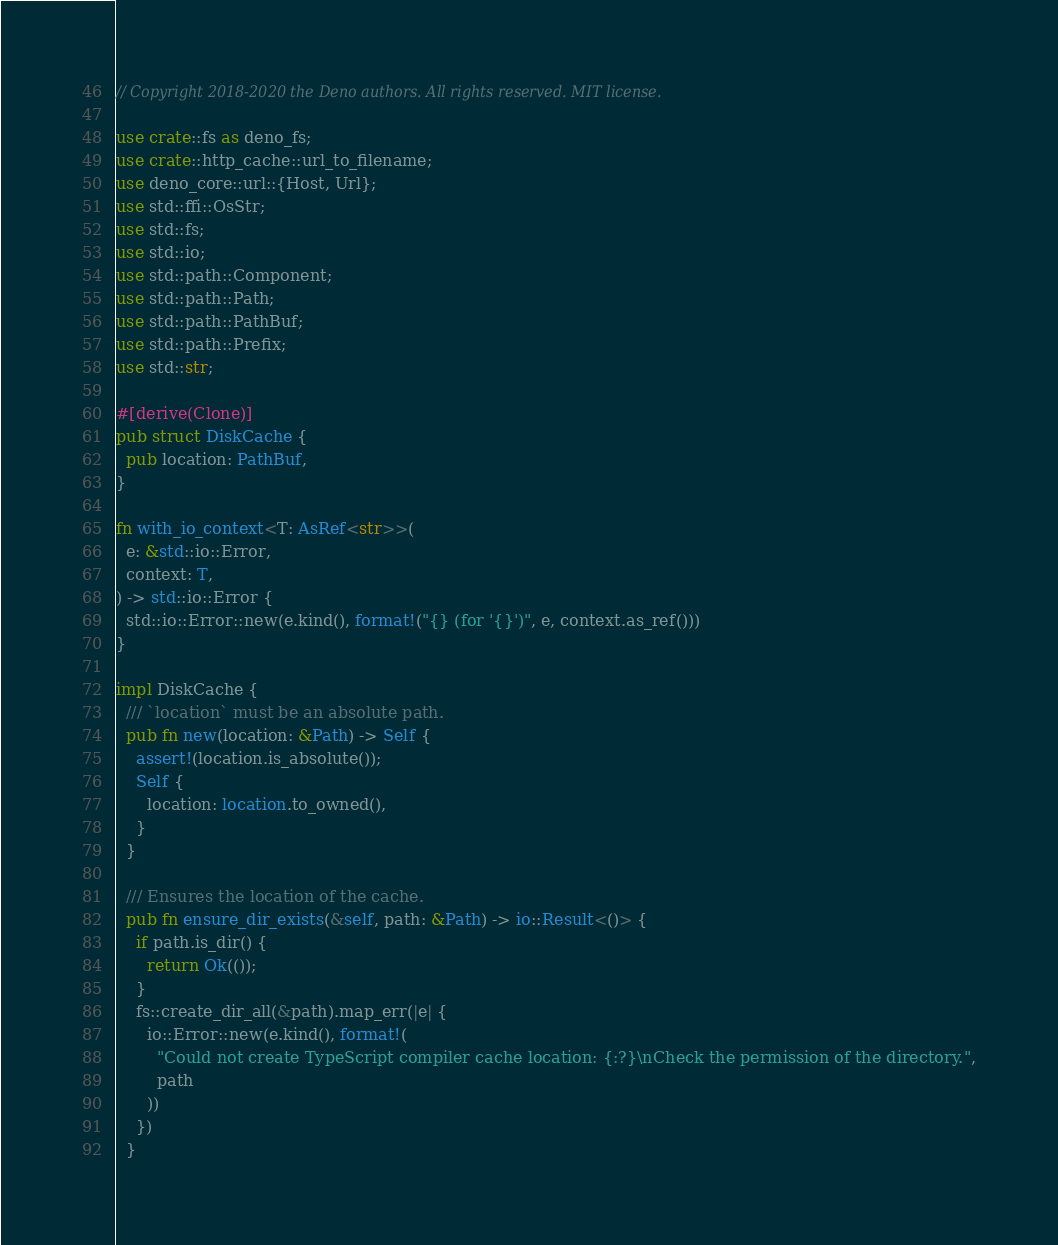Convert code to text. <code><loc_0><loc_0><loc_500><loc_500><_Rust_>// Copyright 2018-2020 the Deno authors. All rights reserved. MIT license.

use crate::fs as deno_fs;
use crate::http_cache::url_to_filename;
use deno_core::url::{Host, Url};
use std::ffi::OsStr;
use std::fs;
use std::io;
use std::path::Component;
use std::path::Path;
use std::path::PathBuf;
use std::path::Prefix;
use std::str;

#[derive(Clone)]
pub struct DiskCache {
  pub location: PathBuf,
}

fn with_io_context<T: AsRef<str>>(
  e: &std::io::Error,
  context: T,
) -> std::io::Error {
  std::io::Error::new(e.kind(), format!("{} (for '{}')", e, context.as_ref()))
}

impl DiskCache {
  /// `location` must be an absolute path.
  pub fn new(location: &Path) -> Self {
    assert!(location.is_absolute());
    Self {
      location: location.to_owned(),
    }
  }

  /// Ensures the location of the cache.
  pub fn ensure_dir_exists(&self, path: &Path) -> io::Result<()> {
    if path.is_dir() {
      return Ok(());
    }
    fs::create_dir_all(&path).map_err(|e| {
      io::Error::new(e.kind(), format!(
        "Could not create TypeScript compiler cache location: {:?}\nCheck the permission of the directory.",
        path
      ))
    })
  }
</code> 